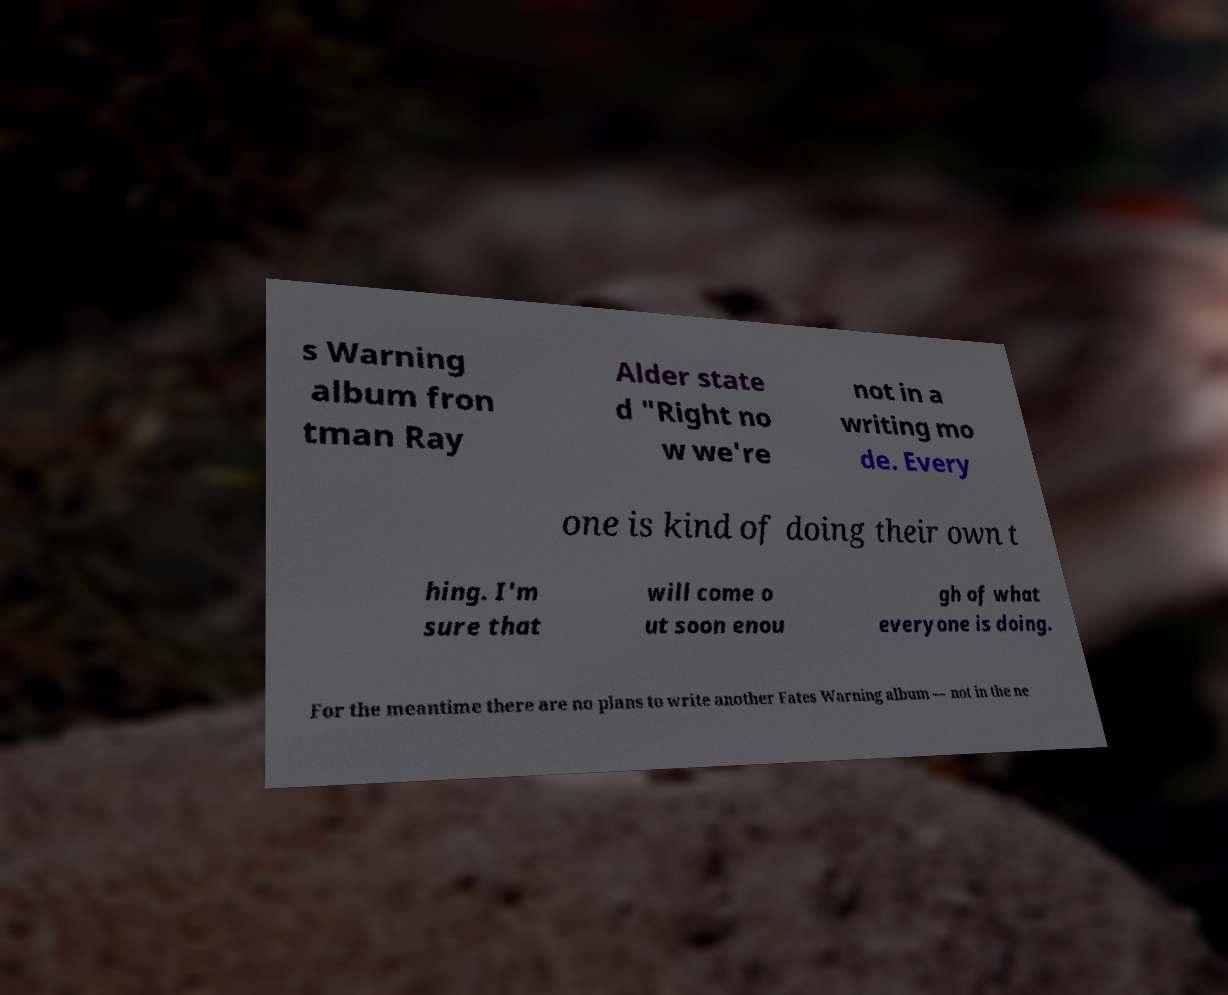Could you assist in decoding the text presented in this image and type it out clearly? s Warning album fron tman Ray Alder state d "Right no w we're not in a writing mo de. Every one is kind of doing their own t hing. I'm sure that will come o ut soon enou gh of what everyone is doing. For the meantime there are no plans to write another Fates Warning album — not in the ne 